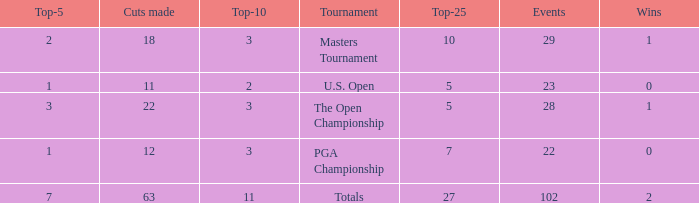How many top 10s did he have when he had fewer than 1 top 5? None. 